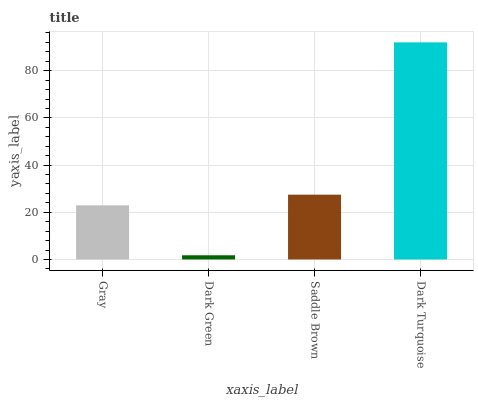Is Dark Green the minimum?
Answer yes or no. Yes. Is Dark Turquoise the maximum?
Answer yes or no. Yes. Is Saddle Brown the minimum?
Answer yes or no. No. Is Saddle Brown the maximum?
Answer yes or no. No. Is Saddle Brown greater than Dark Green?
Answer yes or no. Yes. Is Dark Green less than Saddle Brown?
Answer yes or no. Yes. Is Dark Green greater than Saddle Brown?
Answer yes or no. No. Is Saddle Brown less than Dark Green?
Answer yes or no. No. Is Saddle Brown the high median?
Answer yes or no. Yes. Is Gray the low median?
Answer yes or no. Yes. Is Gray the high median?
Answer yes or no. No. Is Dark Turquoise the low median?
Answer yes or no. No. 